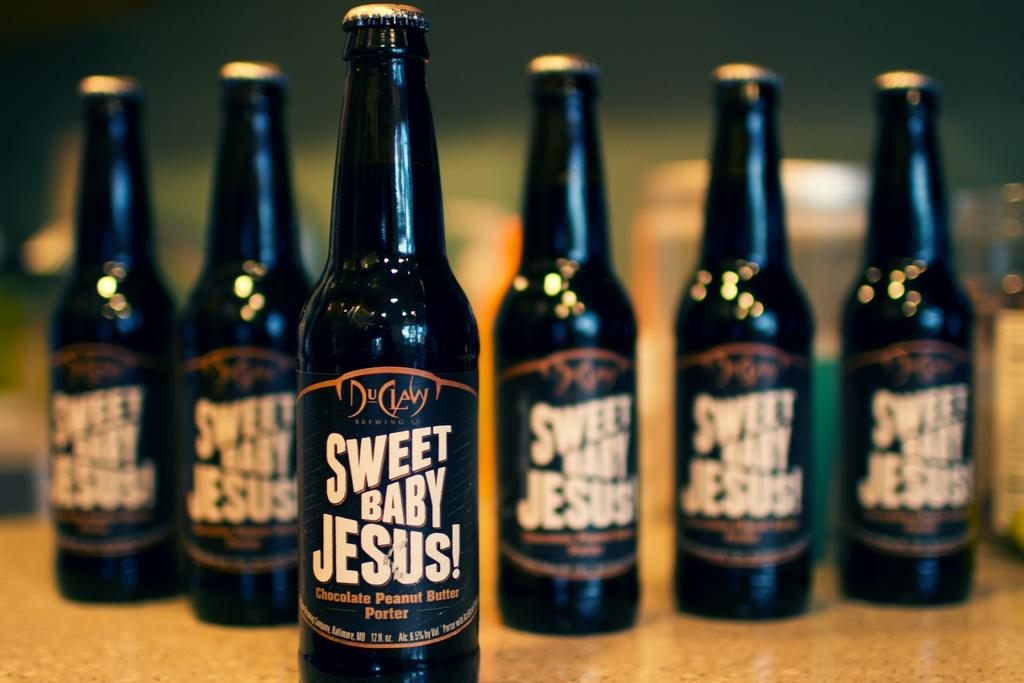<image>
Relay a brief, clear account of the picture shown. Sweet Baby Jesus is on a bottles that are lined up on a table. 